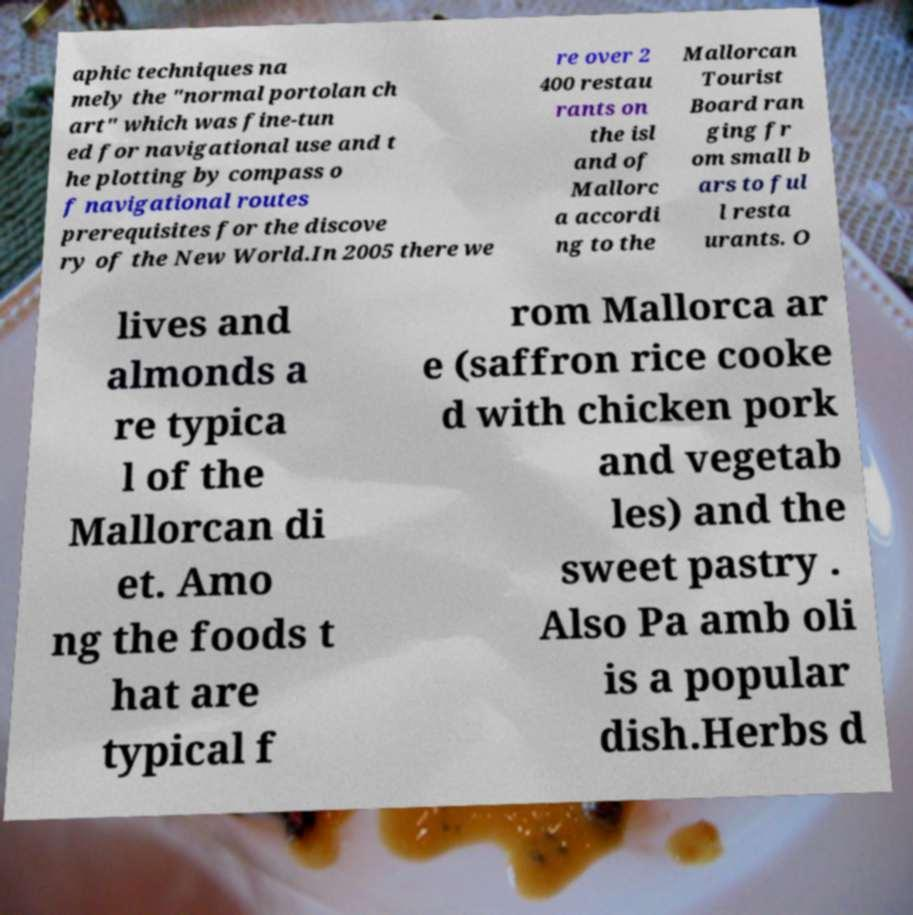Please read and relay the text visible in this image. What does it say? aphic techniques na mely the "normal portolan ch art" which was fine-tun ed for navigational use and t he plotting by compass o f navigational routes prerequisites for the discove ry of the New World.In 2005 there we re over 2 400 restau rants on the isl and of Mallorc a accordi ng to the Mallorcan Tourist Board ran ging fr om small b ars to ful l resta urants. O lives and almonds a re typica l of the Mallorcan di et. Amo ng the foods t hat are typical f rom Mallorca ar e (saffron rice cooke d with chicken pork and vegetab les) and the sweet pastry . Also Pa amb oli is a popular dish.Herbs d 